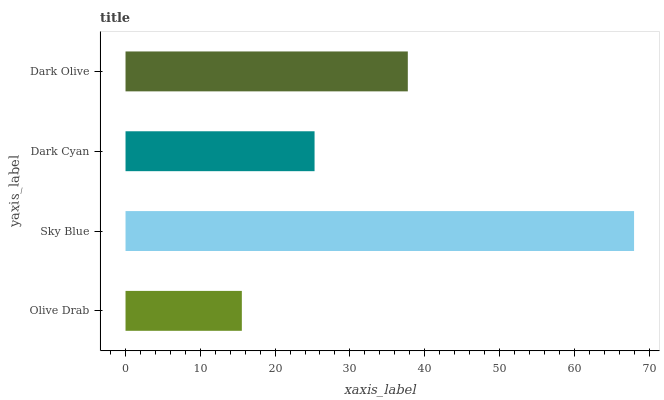Is Olive Drab the minimum?
Answer yes or no. Yes. Is Sky Blue the maximum?
Answer yes or no. Yes. Is Dark Cyan the minimum?
Answer yes or no. No. Is Dark Cyan the maximum?
Answer yes or no. No. Is Sky Blue greater than Dark Cyan?
Answer yes or no. Yes. Is Dark Cyan less than Sky Blue?
Answer yes or no. Yes. Is Dark Cyan greater than Sky Blue?
Answer yes or no. No. Is Sky Blue less than Dark Cyan?
Answer yes or no. No. Is Dark Olive the high median?
Answer yes or no. Yes. Is Dark Cyan the low median?
Answer yes or no. Yes. Is Dark Cyan the high median?
Answer yes or no. No. Is Olive Drab the low median?
Answer yes or no. No. 